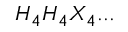Convert formula to latex. <formula><loc_0><loc_0><loc_500><loc_500>H _ { 4 } H _ { 4 } X _ { 4 } \dots</formula> 